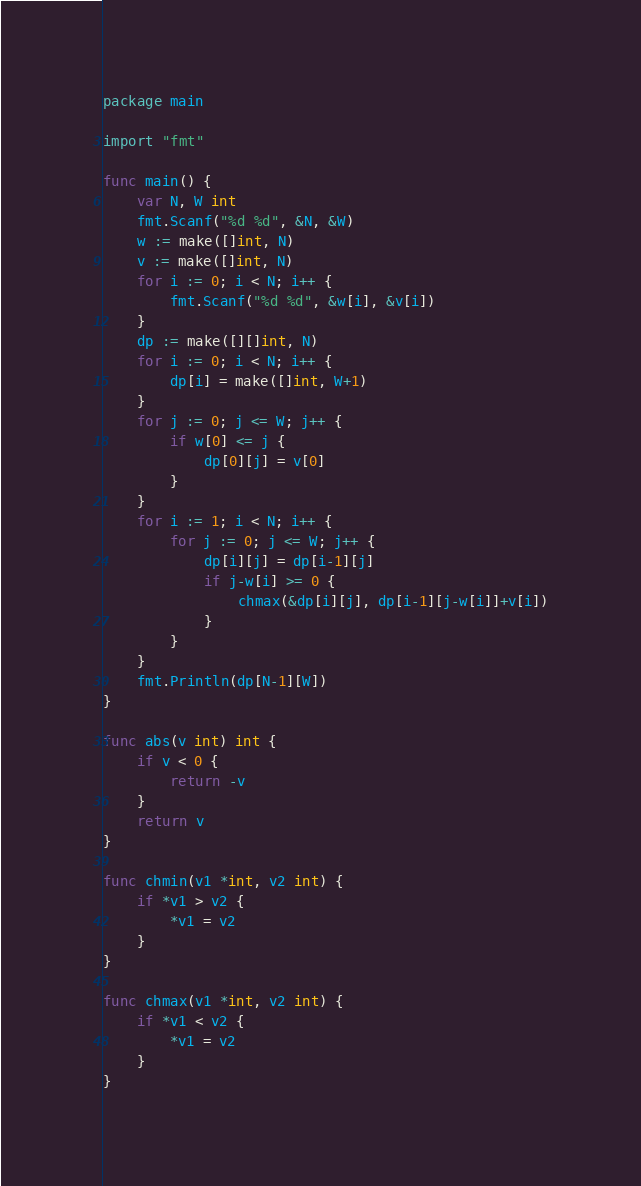<code> <loc_0><loc_0><loc_500><loc_500><_Go_>package main

import "fmt"

func main() {
	var N, W int
	fmt.Scanf("%d %d", &N, &W)
	w := make([]int, N)
	v := make([]int, N)
	for i := 0; i < N; i++ {
		fmt.Scanf("%d %d", &w[i], &v[i])
	}
	dp := make([][]int, N)
	for i := 0; i < N; i++ {
		dp[i] = make([]int, W+1)
	}
	for j := 0; j <= W; j++ {
		if w[0] <= j {
			dp[0][j] = v[0]
		}
	}
	for i := 1; i < N; i++ {
		for j := 0; j <= W; j++ {
			dp[i][j] = dp[i-1][j]
			if j-w[i] >= 0 {
				chmax(&dp[i][j], dp[i-1][j-w[i]]+v[i])
			}
		}
	}
	fmt.Println(dp[N-1][W])
}

func abs(v int) int {
	if v < 0 {
		return -v
	}
	return v
}

func chmin(v1 *int, v2 int) {
	if *v1 > v2 {
		*v1 = v2
	}
}

func chmax(v1 *int, v2 int) {
	if *v1 < v2 {
		*v1 = v2
	}
}
</code> 